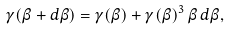<formula> <loc_0><loc_0><loc_500><loc_500>\gamma ( \beta + d \beta ) = \gamma ( \beta ) + \gamma ( \beta ) ^ { 3 } \, \beta \, d \beta ,</formula> 